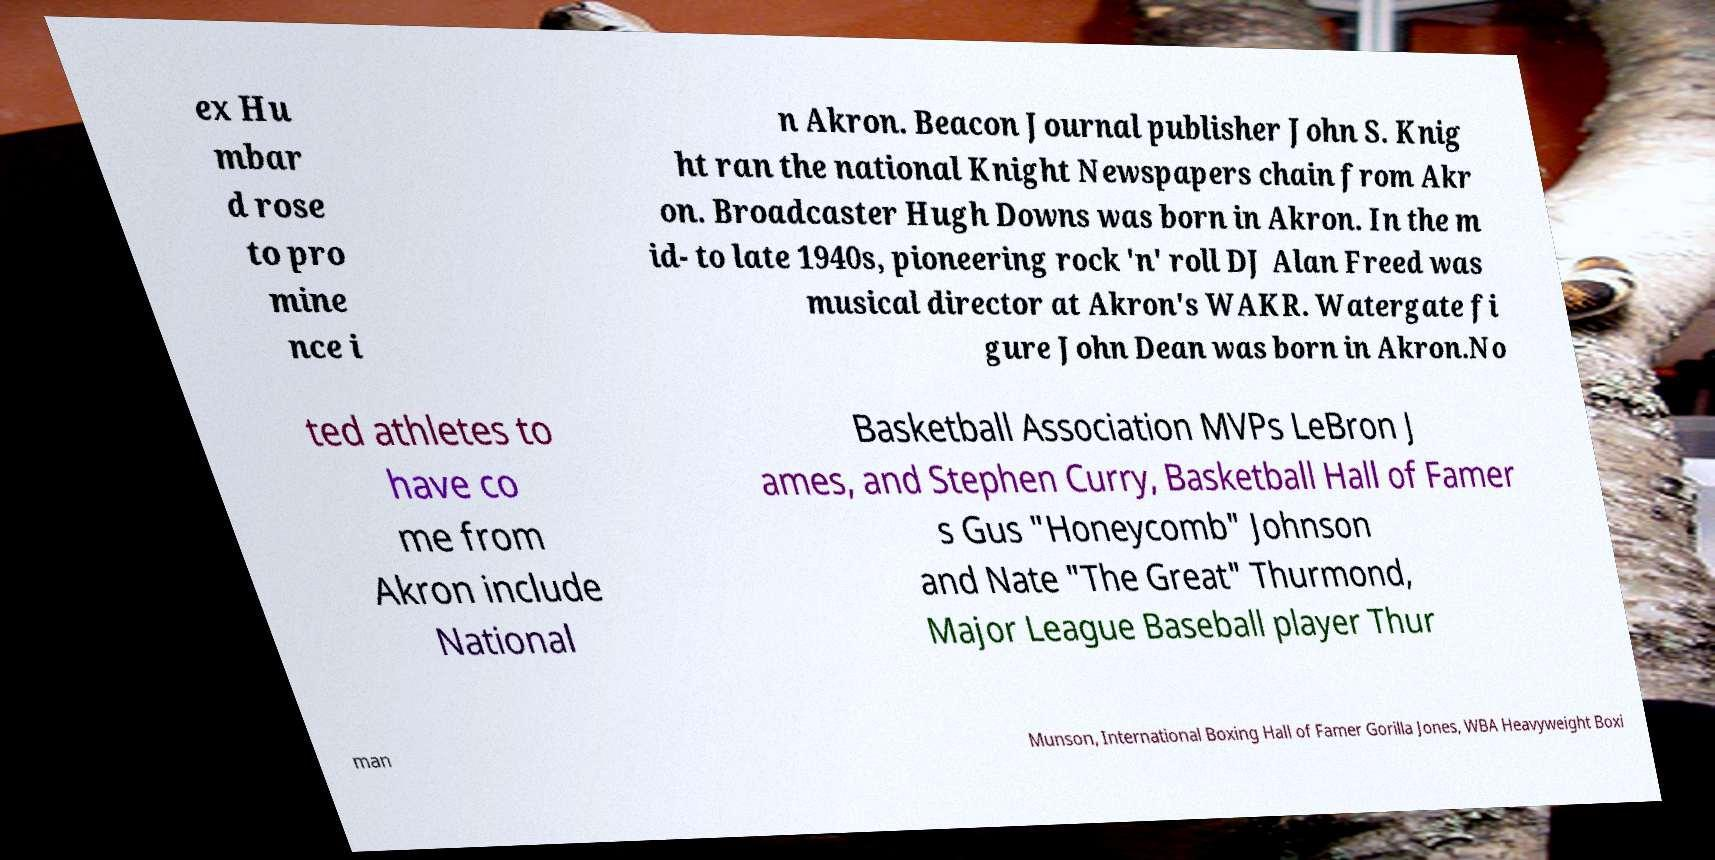For documentation purposes, I need the text within this image transcribed. Could you provide that? ex Hu mbar d rose to pro mine nce i n Akron. Beacon Journal publisher John S. Knig ht ran the national Knight Newspapers chain from Akr on. Broadcaster Hugh Downs was born in Akron. In the m id- to late 1940s, pioneering rock 'n' roll DJ Alan Freed was musical director at Akron's WAKR. Watergate fi gure John Dean was born in Akron.No ted athletes to have co me from Akron include National Basketball Association MVPs LeBron J ames, and Stephen Curry, Basketball Hall of Famer s Gus "Honeycomb" Johnson and Nate "The Great" Thurmond, Major League Baseball player Thur man Munson, International Boxing Hall of Famer Gorilla Jones, WBA Heavyweight Boxi 